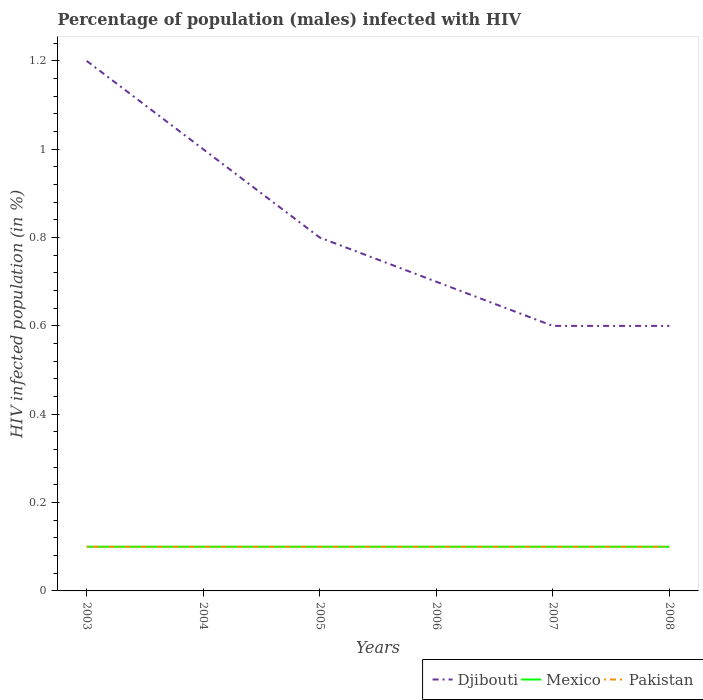Does the line corresponding to Djibouti intersect with the line corresponding to Pakistan?
Your answer should be very brief. No. In which year was the percentage of HIV infected male population in Mexico maximum?
Make the answer very short. 2003. What is the total percentage of HIV infected male population in Mexico in the graph?
Offer a terse response. 0. What is the difference between the highest and the second highest percentage of HIV infected male population in Djibouti?
Make the answer very short. 0.6. How many lines are there?
Make the answer very short. 3. How many years are there in the graph?
Provide a short and direct response. 6. Are the values on the major ticks of Y-axis written in scientific E-notation?
Provide a short and direct response. No. Does the graph contain any zero values?
Keep it short and to the point. No. Does the graph contain grids?
Give a very brief answer. No. How many legend labels are there?
Offer a very short reply. 3. What is the title of the graph?
Your response must be concise. Percentage of population (males) infected with HIV. What is the label or title of the X-axis?
Offer a terse response. Years. What is the label or title of the Y-axis?
Make the answer very short. HIV infected population (in %). What is the HIV infected population (in %) of Djibouti in 2003?
Ensure brevity in your answer.  1.2. What is the HIV infected population (in %) in Mexico in 2003?
Offer a terse response. 0.1. What is the HIV infected population (in %) of Mexico in 2005?
Your response must be concise. 0.1. What is the HIV infected population (in %) of Pakistan in 2006?
Your answer should be very brief. 0.1. What is the HIV infected population (in %) of Djibouti in 2007?
Provide a succinct answer. 0.6. What is the HIV infected population (in %) of Mexico in 2007?
Ensure brevity in your answer.  0.1. What is the HIV infected population (in %) of Djibouti in 2008?
Provide a short and direct response. 0.6. Across all years, what is the maximum HIV infected population (in %) in Mexico?
Your answer should be compact. 0.1. Across all years, what is the maximum HIV infected population (in %) in Pakistan?
Your answer should be compact. 0.1. Across all years, what is the minimum HIV infected population (in %) in Djibouti?
Keep it short and to the point. 0.6. Across all years, what is the minimum HIV infected population (in %) of Mexico?
Provide a succinct answer. 0.1. What is the total HIV infected population (in %) in Mexico in the graph?
Offer a very short reply. 0.6. What is the difference between the HIV infected population (in %) of Djibouti in 2003 and that in 2004?
Offer a very short reply. 0.2. What is the difference between the HIV infected population (in %) of Mexico in 2003 and that in 2004?
Keep it short and to the point. 0. What is the difference between the HIV infected population (in %) in Pakistan in 2003 and that in 2004?
Your answer should be very brief. 0. What is the difference between the HIV infected population (in %) in Pakistan in 2003 and that in 2005?
Keep it short and to the point. 0. What is the difference between the HIV infected population (in %) in Djibouti in 2003 and that in 2007?
Offer a terse response. 0.6. What is the difference between the HIV infected population (in %) in Mexico in 2003 and that in 2007?
Offer a terse response. 0. What is the difference between the HIV infected population (in %) in Pakistan in 2003 and that in 2007?
Make the answer very short. 0. What is the difference between the HIV infected population (in %) of Djibouti in 2003 and that in 2008?
Offer a terse response. 0.6. What is the difference between the HIV infected population (in %) in Pakistan in 2003 and that in 2008?
Your response must be concise. 0. What is the difference between the HIV infected population (in %) in Djibouti in 2004 and that in 2005?
Provide a short and direct response. 0.2. What is the difference between the HIV infected population (in %) in Pakistan in 2004 and that in 2005?
Give a very brief answer. 0. What is the difference between the HIV infected population (in %) of Djibouti in 2004 and that in 2006?
Give a very brief answer. 0.3. What is the difference between the HIV infected population (in %) in Pakistan in 2004 and that in 2006?
Your answer should be very brief. 0. What is the difference between the HIV infected population (in %) of Djibouti in 2004 and that in 2008?
Your response must be concise. 0.4. What is the difference between the HIV infected population (in %) in Mexico in 2004 and that in 2008?
Your answer should be very brief. 0. What is the difference between the HIV infected population (in %) in Pakistan in 2004 and that in 2008?
Offer a terse response. 0. What is the difference between the HIV infected population (in %) of Djibouti in 2005 and that in 2006?
Provide a succinct answer. 0.1. What is the difference between the HIV infected population (in %) in Pakistan in 2005 and that in 2006?
Your response must be concise. 0. What is the difference between the HIV infected population (in %) of Djibouti in 2005 and that in 2007?
Make the answer very short. 0.2. What is the difference between the HIV infected population (in %) of Pakistan in 2005 and that in 2007?
Offer a terse response. 0. What is the difference between the HIV infected population (in %) of Pakistan in 2005 and that in 2008?
Keep it short and to the point. 0. What is the difference between the HIV infected population (in %) in Mexico in 2006 and that in 2007?
Your answer should be very brief. 0. What is the difference between the HIV infected population (in %) in Mexico in 2006 and that in 2008?
Your answer should be very brief. 0. What is the difference between the HIV infected population (in %) of Pakistan in 2006 and that in 2008?
Ensure brevity in your answer.  0. What is the difference between the HIV infected population (in %) in Djibouti in 2007 and that in 2008?
Keep it short and to the point. 0. What is the difference between the HIV infected population (in %) of Mexico in 2007 and that in 2008?
Provide a succinct answer. 0. What is the difference between the HIV infected population (in %) in Pakistan in 2007 and that in 2008?
Provide a succinct answer. 0. What is the difference between the HIV infected population (in %) in Djibouti in 2003 and the HIV infected population (in %) in Mexico in 2004?
Your answer should be compact. 1.1. What is the difference between the HIV infected population (in %) in Djibouti in 2003 and the HIV infected population (in %) in Pakistan in 2004?
Your answer should be compact. 1.1. What is the difference between the HIV infected population (in %) in Mexico in 2003 and the HIV infected population (in %) in Pakistan in 2004?
Offer a terse response. 0. What is the difference between the HIV infected population (in %) in Djibouti in 2003 and the HIV infected population (in %) in Pakistan in 2005?
Offer a terse response. 1.1. What is the difference between the HIV infected population (in %) of Djibouti in 2003 and the HIV infected population (in %) of Mexico in 2006?
Your response must be concise. 1.1. What is the difference between the HIV infected population (in %) in Mexico in 2003 and the HIV infected population (in %) in Pakistan in 2007?
Offer a terse response. 0. What is the difference between the HIV infected population (in %) of Djibouti in 2003 and the HIV infected population (in %) of Mexico in 2008?
Your answer should be compact. 1.1. What is the difference between the HIV infected population (in %) of Djibouti in 2003 and the HIV infected population (in %) of Pakistan in 2008?
Your answer should be compact. 1.1. What is the difference between the HIV infected population (in %) of Mexico in 2003 and the HIV infected population (in %) of Pakistan in 2008?
Provide a short and direct response. 0. What is the difference between the HIV infected population (in %) in Djibouti in 2004 and the HIV infected population (in %) in Pakistan in 2006?
Keep it short and to the point. 0.9. What is the difference between the HIV infected population (in %) in Mexico in 2004 and the HIV infected population (in %) in Pakistan in 2006?
Offer a very short reply. 0. What is the difference between the HIV infected population (in %) of Djibouti in 2004 and the HIV infected population (in %) of Pakistan in 2007?
Provide a succinct answer. 0.9. What is the difference between the HIV infected population (in %) of Mexico in 2004 and the HIV infected population (in %) of Pakistan in 2007?
Your response must be concise. 0. What is the difference between the HIV infected population (in %) of Djibouti in 2004 and the HIV infected population (in %) of Mexico in 2008?
Provide a succinct answer. 0.9. What is the difference between the HIV infected population (in %) of Djibouti in 2004 and the HIV infected population (in %) of Pakistan in 2008?
Keep it short and to the point. 0.9. What is the difference between the HIV infected population (in %) of Djibouti in 2005 and the HIV infected population (in %) of Pakistan in 2006?
Offer a terse response. 0.7. What is the difference between the HIV infected population (in %) of Mexico in 2005 and the HIV infected population (in %) of Pakistan in 2006?
Give a very brief answer. 0. What is the difference between the HIV infected population (in %) of Djibouti in 2005 and the HIV infected population (in %) of Mexico in 2007?
Provide a succinct answer. 0.7. What is the difference between the HIV infected population (in %) in Djibouti in 2005 and the HIV infected population (in %) in Pakistan in 2007?
Provide a short and direct response. 0.7. What is the difference between the HIV infected population (in %) in Mexico in 2005 and the HIV infected population (in %) in Pakistan in 2007?
Offer a terse response. 0. What is the difference between the HIV infected population (in %) of Mexico in 2005 and the HIV infected population (in %) of Pakistan in 2008?
Give a very brief answer. 0. What is the difference between the HIV infected population (in %) in Djibouti in 2006 and the HIV infected population (in %) in Mexico in 2007?
Offer a terse response. 0.6. What is the difference between the HIV infected population (in %) in Djibouti in 2006 and the HIV infected population (in %) in Pakistan in 2007?
Ensure brevity in your answer.  0.6. What is the average HIV infected population (in %) of Djibouti per year?
Offer a very short reply. 0.82. In the year 2003, what is the difference between the HIV infected population (in %) in Djibouti and HIV infected population (in %) in Mexico?
Your answer should be very brief. 1.1. In the year 2003, what is the difference between the HIV infected population (in %) in Djibouti and HIV infected population (in %) in Pakistan?
Give a very brief answer. 1.1. In the year 2003, what is the difference between the HIV infected population (in %) of Mexico and HIV infected population (in %) of Pakistan?
Your response must be concise. 0. In the year 2004, what is the difference between the HIV infected population (in %) of Djibouti and HIV infected population (in %) of Mexico?
Provide a short and direct response. 0.9. In the year 2004, what is the difference between the HIV infected population (in %) of Djibouti and HIV infected population (in %) of Pakistan?
Offer a terse response. 0.9. In the year 2005, what is the difference between the HIV infected population (in %) of Djibouti and HIV infected population (in %) of Mexico?
Offer a very short reply. 0.7. In the year 2005, what is the difference between the HIV infected population (in %) of Mexico and HIV infected population (in %) of Pakistan?
Provide a short and direct response. 0. In the year 2006, what is the difference between the HIV infected population (in %) in Djibouti and HIV infected population (in %) in Mexico?
Keep it short and to the point. 0.6. In the year 2006, what is the difference between the HIV infected population (in %) of Djibouti and HIV infected population (in %) of Pakistan?
Provide a succinct answer. 0.6. In the year 2006, what is the difference between the HIV infected population (in %) of Mexico and HIV infected population (in %) of Pakistan?
Provide a succinct answer. 0. In the year 2007, what is the difference between the HIV infected population (in %) in Djibouti and HIV infected population (in %) in Mexico?
Provide a short and direct response. 0.5. In the year 2007, what is the difference between the HIV infected population (in %) in Mexico and HIV infected population (in %) in Pakistan?
Provide a short and direct response. 0. In the year 2008, what is the difference between the HIV infected population (in %) in Djibouti and HIV infected population (in %) in Mexico?
Your answer should be very brief. 0.5. In the year 2008, what is the difference between the HIV infected population (in %) in Djibouti and HIV infected population (in %) in Pakistan?
Your answer should be very brief. 0.5. What is the ratio of the HIV infected population (in %) in Pakistan in 2003 to that in 2004?
Offer a very short reply. 1. What is the ratio of the HIV infected population (in %) of Djibouti in 2003 to that in 2005?
Your response must be concise. 1.5. What is the ratio of the HIV infected population (in %) in Pakistan in 2003 to that in 2005?
Ensure brevity in your answer.  1. What is the ratio of the HIV infected population (in %) in Djibouti in 2003 to that in 2006?
Your response must be concise. 1.71. What is the ratio of the HIV infected population (in %) in Mexico in 2003 to that in 2006?
Give a very brief answer. 1. What is the ratio of the HIV infected population (in %) of Pakistan in 2003 to that in 2006?
Ensure brevity in your answer.  1. What is the ratio of the HIV infected population (in %) of Pakistan in 2003 to that in 2007?
Offer a very short reply. 1. What is the ratio of the HIV infected population (in %) in Mexico in 2003 to that in 2008?
Your answer should be compact. 1. What is the ratio of the HIV infected population (in %) of Pakistan in 2003 to that in 2008?
Ensure brevity in your answer.  1. What is the ratio of the HIV infected population (in %) of Djibouti in 2004 to that in 2005?
Offer a very short reply. 1.25. What is the ratio of the HIV infected population (in %) of Mexico in 2004 to that in 2005?
Offer a very short reply. 1. What is the ratio of the HIV infected population (in %) of Djibouti in 2004 to that in 2006?
Give a very brief answer. 1.43. What is the ratio of the HIV infected population (in %) of Mexico in 2004 to that in 2006?
Make the answer very short. 1. What is the ratio of the HIV infected population (in %) of Djibouti in 2004 to that in 2007?
Your answer should be compact. 1.67. What is the ratio of the HIV infected population (in %) of Djibouti in 2004 to that in 2008?
Provide a succinct answer. 1.67. What is the ratio of the HIV infected population (in %) of Mexico in 2004 to that in 2008?
Your answer should be very brief. 1. What is the ratio of the HIV infected population (in %) in Djibouti in 2005 to that in 2006?
Offer a very short reply. 1.14. What is the ratio of the HIV infected population (in %) in Pakistan in 2005 to that in 2006?
Keep it short and to the point. 1. What is the ratio of the HIV infected population (in %) of Djibouti in 2005 to that in 2007?
Your answer should be very brief. 1.33. What is the ratio of the HIV infected population (in %) in Pakistan in 2005 to that in 2007?
Offer a terse response. 1. What is the ratio of the HIV infected population (in %) in Djibouti in 2005 to that in 2008?
Offer a very short reply. 1.33. What is the ratio of the HIV infected population (in %) in Mexico in 2005 to that in 2008?
Offer a terse response. 1. What is the ratio of the HIV infected population (in %) of Djibouti in 2006 to that in 2007?
Give a very brief answer. 1.17. What is the ratio of the HIV infected population (in %) of Djibouti in 2006 to that in 2008?
Your answer should be very brief. 1.17. What is the ratio of the HIV infected population (in %) in Pakistan in 2006 to that in 2008?
Ensure brevity in your answer.  1. What is the ratio of the HIV infected population (in %) in Djibouti in 2007 to that in 2008?
Ensure brevity in your answer.  1. What is the difference between the highest and the second highest HIV infected population (in %) in Mexico?
Provide a succinct answer. 0. What is the difference between the highest and the second highest HIV infected population (in %) of Pakistan?
Keep it short and to the point. 0. What is the difference between the highest and the lowest HIV infected population (in %) in Djibouti?
Keep it short and to the point. 0.6. 